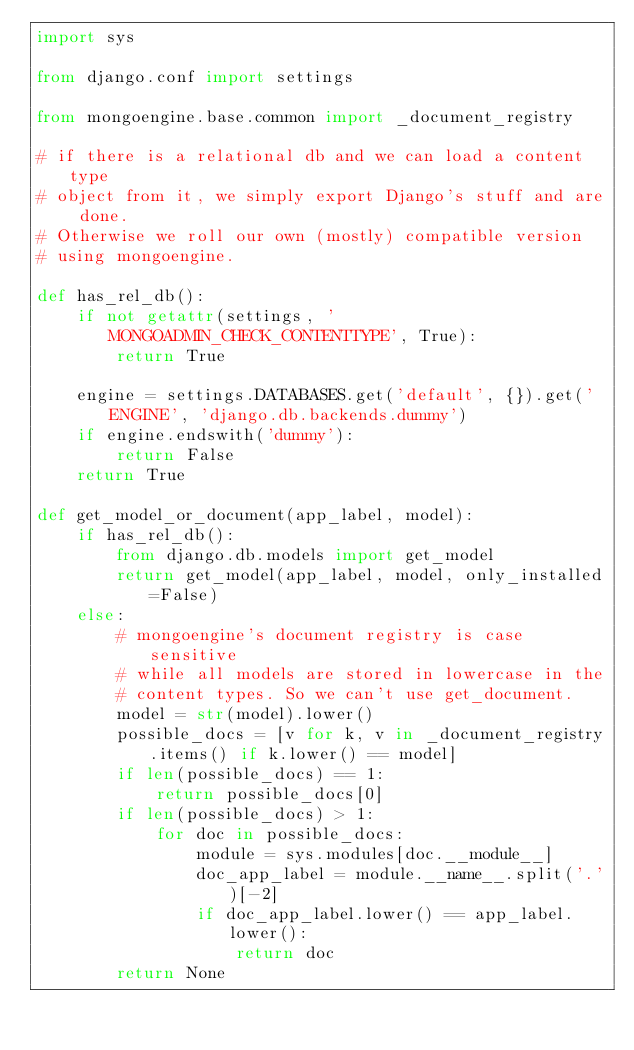<code> <loc_0><loc_0><loc_500><loc_500><_Python_>import sys

from django.conf import settings

from mongoengine.base.common import _document_registry

# if there is a relational db and we can load a content type
# object from it, we simply export Django's stuff and are done.
# Otherwise we roll our own (mostly) compatible version 
# using mongoengine.

def has_rel_db():
    if not getattr(settings, 'MONGOADMIN_CHECK_CONTENTTYPE', True):
        return True
    
    engine = settings.DATABASES.get('default', {}).get('ENGINE', 'django.db.backends.dummy')
    if engine.endswith('dummy'):
        return False
    return True
    
def get_model_or_document(app_label, model):
    if has_rel_db():
        from django.db.models import get_model
        return get_model(app_label, model, only_installed=False)
    else:
        # mongoengine's document registry is case sensitive
        # while all models are stored in lowercase in the
        # content types. So we can't use get_document.
        model = str(model).lower()
        possible_docs = [v for k, v in _document_registry.items() if k.lower() == model]
        if len(possible_docs) == 1:
            return possible_docs[0]
        if len(possible_docs) > 1:
            for doc in possible_docs:
                module = sys.modules[doc.__module__]
                doc_app_label = module.__name__.split('.')[-2]
                if doc_app_label.lower() == app_label.lower():
                    return doc
        return None</code> 